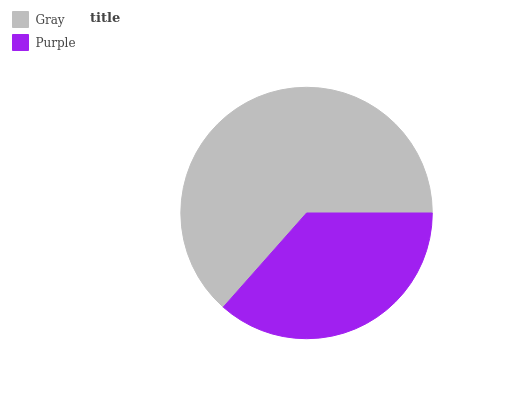Is Purple the minimum?
Answer yes or no. Yes. Is Gray the maximum?
Answer yes or no. Yes. Is Purple the maximum?
Answer yes or no. No. Is Gray greater than Purple?
Answer yes or no. Yes. Is Purple less than Gray?
Answer yes or no. Yes. Is Purple greater than Gray?
Answer yes or no. No. Is Gray less than Purple?
Answer yes or no. No. Is Gray the high median?
Answer yes or no. Yes. Is Purple the low median?
Answer yes or no. Yes. Is Purple the high median?
Answer yes or no. No. Is Gray the low median?
Answer yes or no. No. 